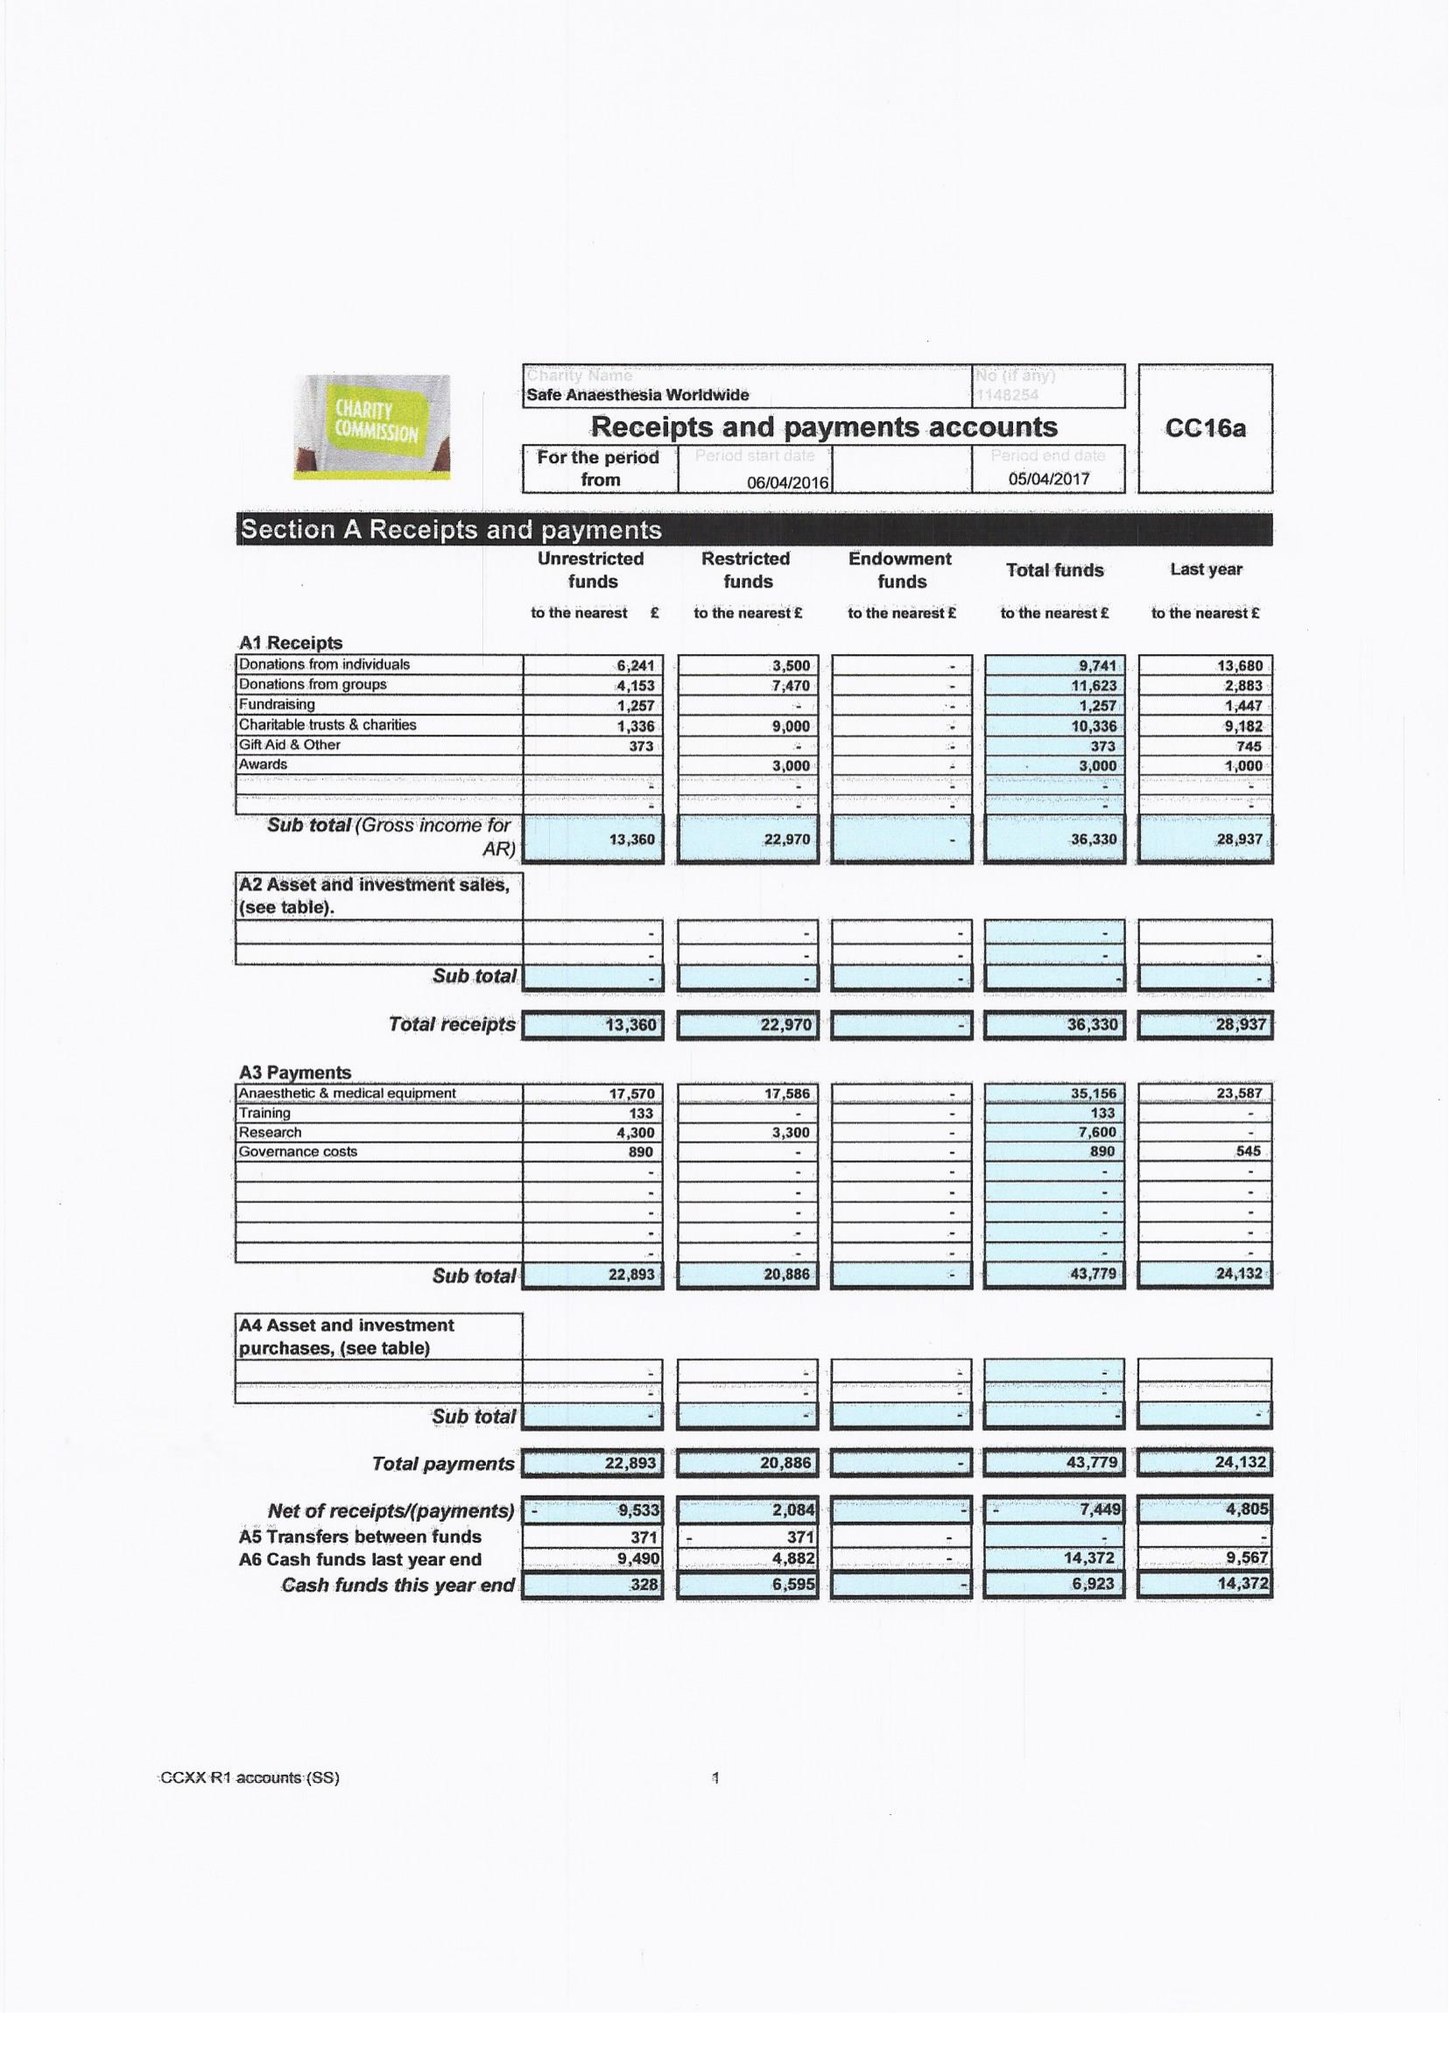What is the value for the charity_name?
Answer the question using a single word or phrase. Safe Anaesthesia Worldwide 